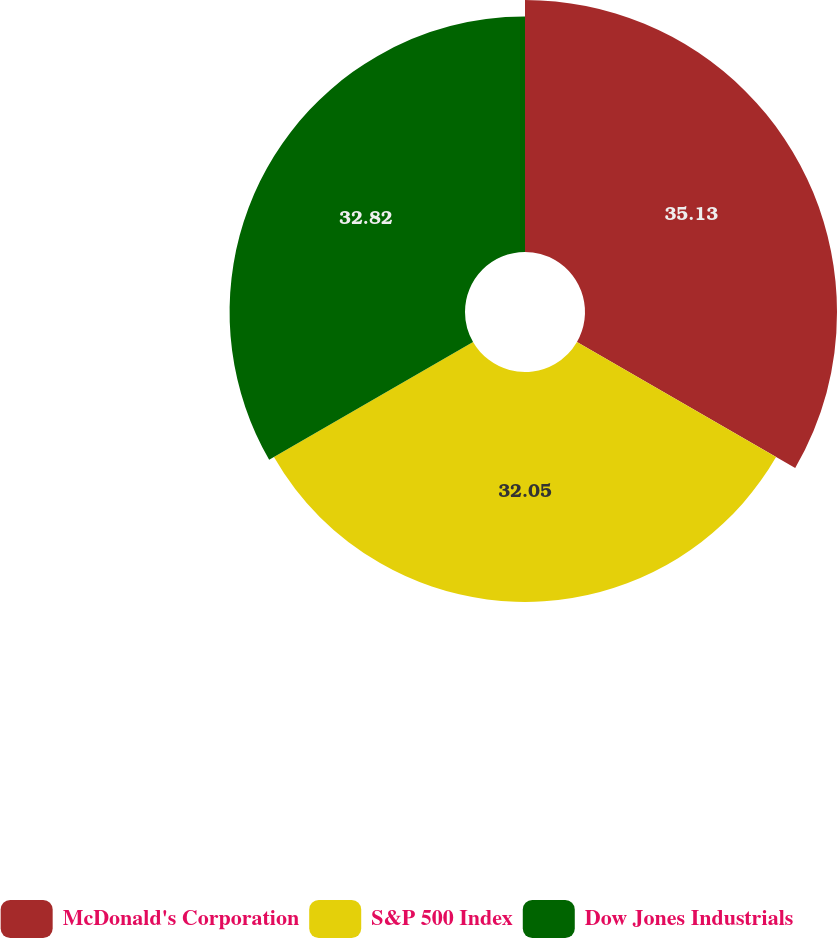<chart> <loc_0><loc_0><loc_500><loc_500><pie_chart><fcel>McDonald's Corporation<fcel>S&P 500 Index<fcel>Dow Jones Industrials<nl><fcel>35.13%<fcel>32.05%<fcel>32.82%<nl></chart> 